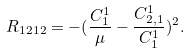Convert formula to latex. <formula><loc_0><loc_0><loc_500><loc_500>R _ { 1 2 1 2 } = - ( \frac { C ^ { 1 } _ { 1 } } { \mu } - \frac { C ^ { 1 } _ { 2 , 1 } } { C ^ { 1 } _ { 1 } } ) ^ { 2 } .</formula> 